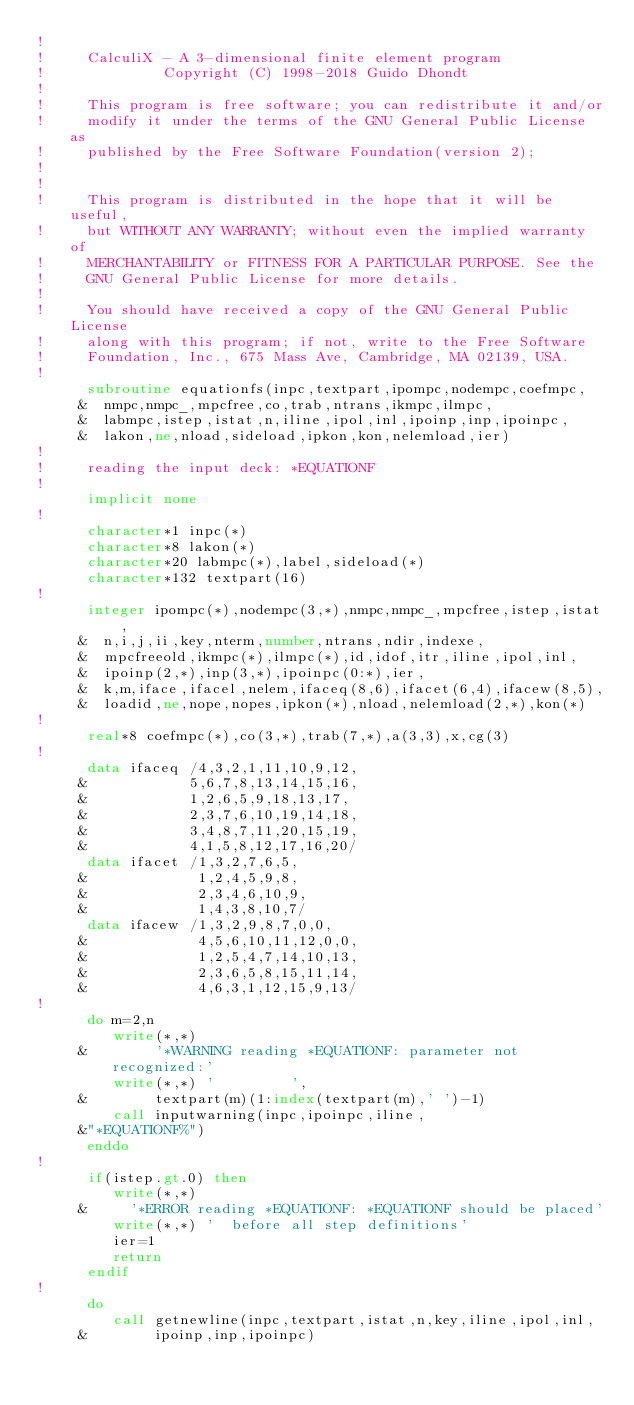<code> <loc_0><loc_0><loc_500><loc_500><_FORTRAN_>!
!     CalculiX - A 3-dimensional finite element program
!              Copyright (C) 1998-2018 Guido Dhondt
!
!     This program is free software; you can redistribute it and/or
!     modify it under the terms of the GNU General Public License as
!     published by the Free Software Foundation(version 2);
!     
!
!     This program is distributed in the hope that it will be useful,
!     but WITHOUT ANY WARRANTY; without even the implied warranty of 
!     MERCHANTABILITY or FITNESS FOR A PARTICULAR PURPOSE. See the 
!     GNU General Public License for more details.
!
!     You should have received a copy of the GNU General Public License
!     along with this program; if not, write to the Free Software
!     Foundation, Inc., 675 Mass Ave, Cambridge, MA 02139, USA.
!
      subroutine equationfs(inpc,textpart,ipompc,nodempc,coefmpc,
     &  nmpc,nmpc_,mpcfree,co,trab,ntrans,ikmpc,ilmpc,
     &  labmpc,istep,istat,n,iline,ipol,inl,ipoinp,inp,ipoinpc,
     &  lakon,ne,nload,sideload,ipkon,kon,nelemload,ier)
!
!     reading the input deck: *EQUATIONF
!
      implicit none
!
      character*1 inpc(*)
      character*8 lakon(*)
      character*20 labmpc(*),label,sideload(*)
      character*132 textpart(16)
!
      integer ipompc(*),nodempc(3,*),nmpc,nmpc_,mpcfree,istep,istat,
     &  n,i,j,ii,key,nterm,number,ntrans,ndir,indexe,
     &  mpcfreeold,ikmpc(*),ilmpc(*),id,idof,itr,iline,ipol,inl,
     &  ipoinp(2,*),inp(3,*),ipoinpc(0:*),ier,
     &  k,m,iface,ifacel,nelem,ifaceq(8,6),ifacet(6,4),ifacew(8,5),
     &  loadid,ne,nope,nopes,ipkon(*),nload,nelemload(2,*),kon(*)
!
      real*8 coefmpc(*),co(3,*),trab(7,*),a(3,3),x,cg(3)
!
      data ifaceq /4,3,2,1,11,10,9,12,
     &            5,6,7,8,13,14,15,16,
     &            1,2,6,5,9,18,13,17,
     &            2,3,7,6,10,19,14,18,
     &            3,4,8,7,11,20,15,19,
     &            4,1,5,8,12,17,16,20/
      data ifacet /1,3,2,7,6,5,
     &             1,2,4,5,9,8,
     &             2,3,4,6,10,9,
     &             1,4,3,8,10,7/
      data ifacew /1,3,2,9,8,7,0,0,
     &             4,5,6,10,11,12,0,0,
     &             1,2,5,4,7,14,10,13,
     &             2,3,6,5,8,15,11,14,
     &             4,6,3,1,12,15,9,13/
!
      do m=2,n
         write(*,*) 
     &        '*WARNING reading *EQUATIONF: parameter not recognized:'
         write(*,*) '         ',
     &        textpart(m)(1:index(textpart(m),' ')-1)
         call inputwarning(inpc,ipoinpc,iline,
     &"*EQUATIONF%")
      enddo
!
      if(istep.gt.0) then
         write(*,*) 
     &     '*ERROR reading *EQUATIONF: *EQUATIONF should be placed'
         write(*,*) '  before all step definitions'
         ier=1
         return
      endif
!
      do
         call getnewline(inpc,textpart,istat,n,key,iline,ipol,inl,
     &        ipoinp,inp,ipoinpc)</code> 